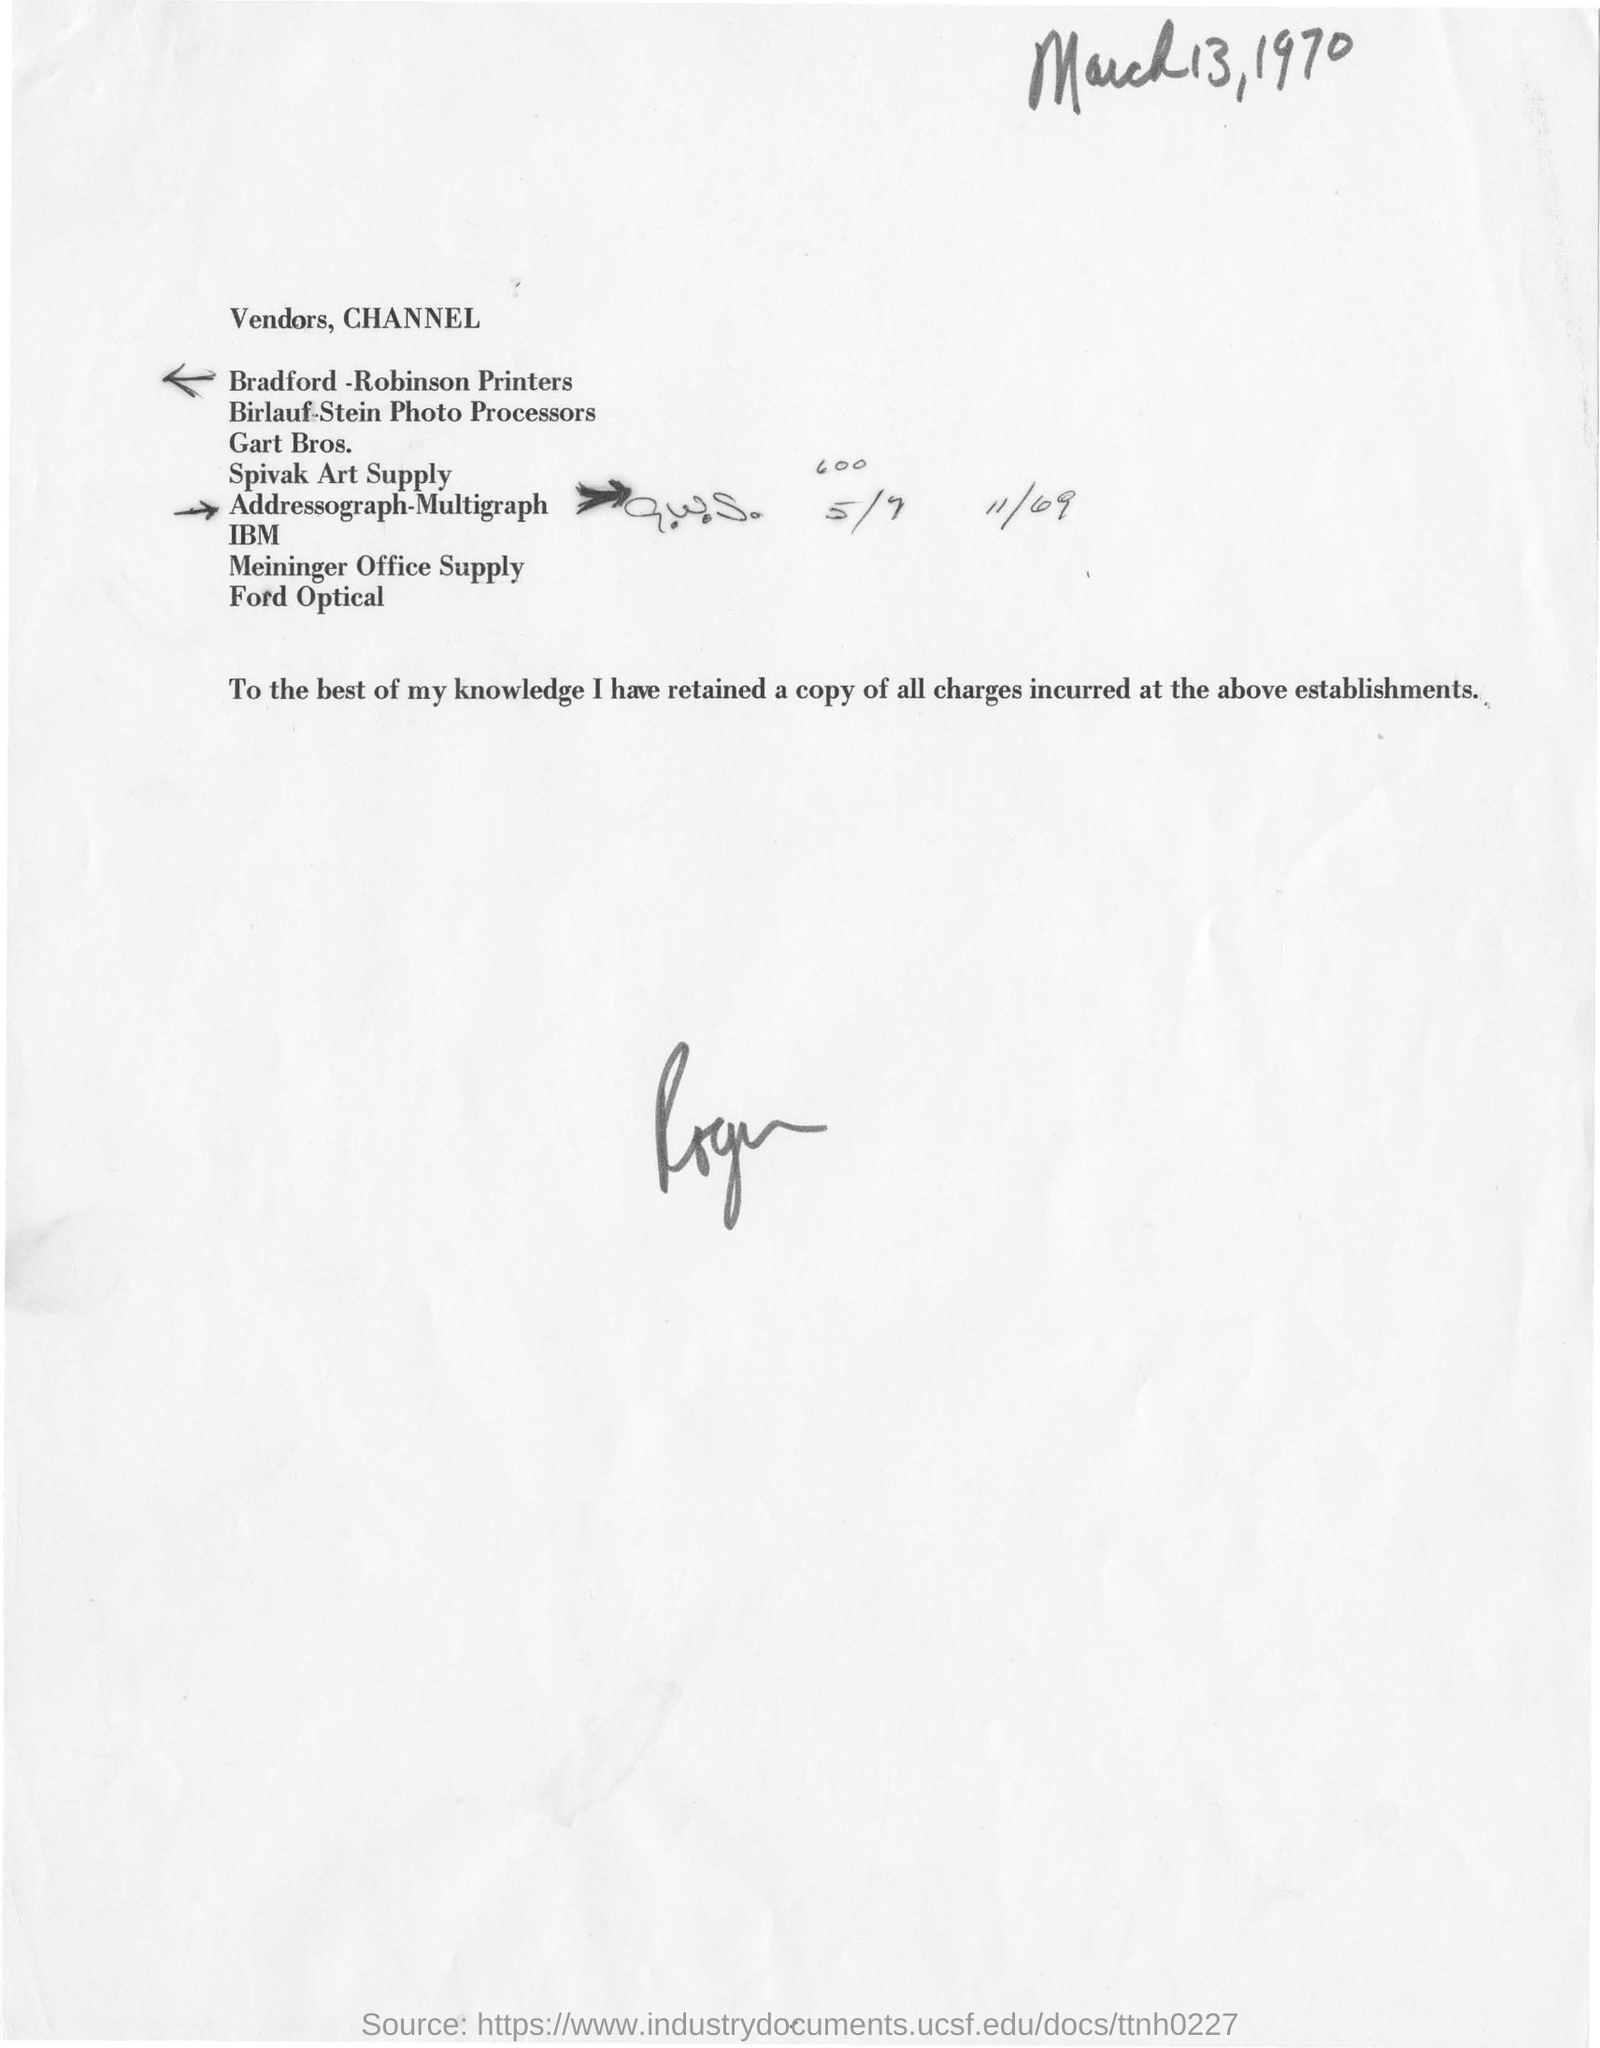What is the date mentioned in this document?
Provide a short and direct response. March13, 1970. What is the name of the printers mentioned here?
Offer a terse response. Bradford -Robinson Printers. 